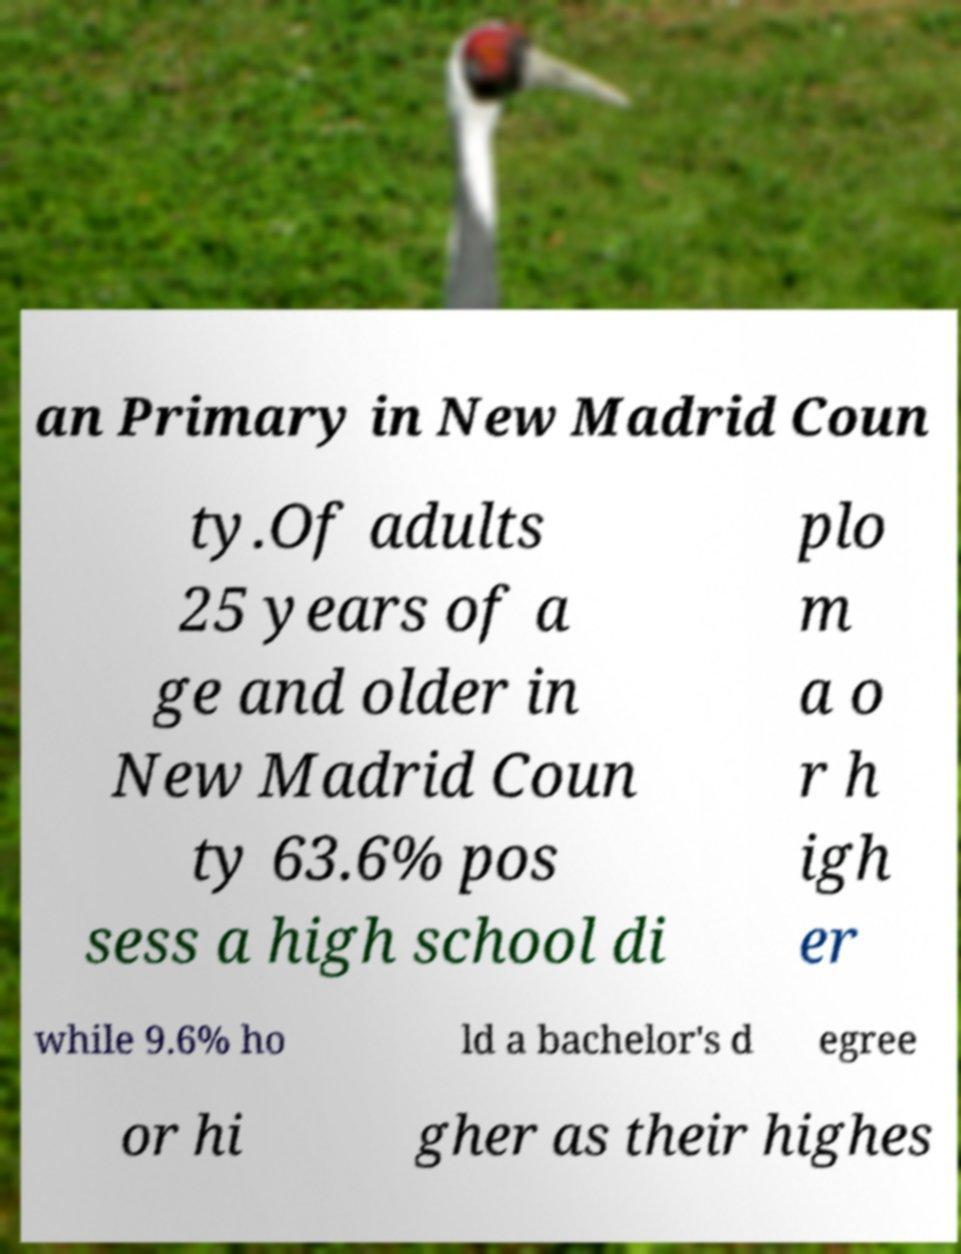Can you accurately transcribe the text from the provided image for me? an Primary in New Madrid Coun ty.Of adults 25 years of a ge and older in New Madrid Coun ty 63.6% pos sess a high school di plo m a o r h igh er while 9.6% ho ld a bachelor's d egree or hi gher as their highes 